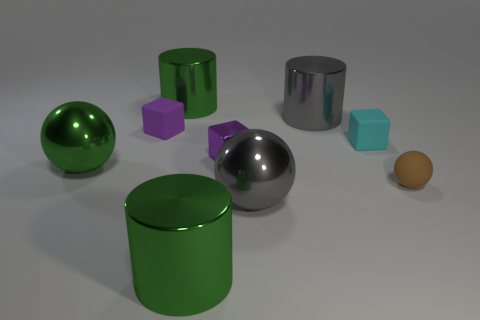What number of objects are metal cubes or small purple cubes? In the image, there appears to be one small purple cube. There are no metal cubes; however, there are two objects that might look metallic due to their shiny surfaces—a silver sphere and a cylinder. Therefore, based on visible characteristics, there is only one object that precisely matches the description. 